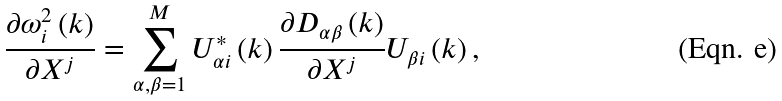Convert formula to latex. <formula><loc_0><loc_0><loc_500><loc_500>\frac { \partial \omega ^ { 2 } _ { i } \left ( k \right ) } { \partial X ^ { j } } = \sum _ { \alpha , \beta = 1 } ^ { M } U ^ { * } _ { \alpha i } \left ( k \right ) \frac { \partial D _ { \alpha \beta } \left ( k \right ) } { \partial X ^ { j } } U _ { \beta i } \left ( k \right ) ,</formula> 